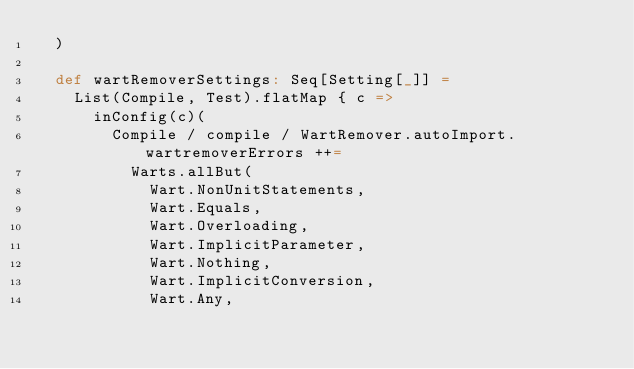Convert code to text. <code><loc_0><loc_0><loc_500><loc_500><_Scala_>  )

  def wartRemoverSettings: Seq[Setting[_]] =
    List(Compile, Test).flatMap { c =>
      inConfig(c)(
        Compile / compile / WartRemover.autoImport.wartremoverErrors ++=
          Warts.allBut(
            Wart.NonUnitStatements,
            Wart.Equals,
            Wart.Overloading,
            Wart.ImplicitParameter,
            Wart.Nothing,
            Wart.ImplicitConversion,
            Wart.Any,</code> 